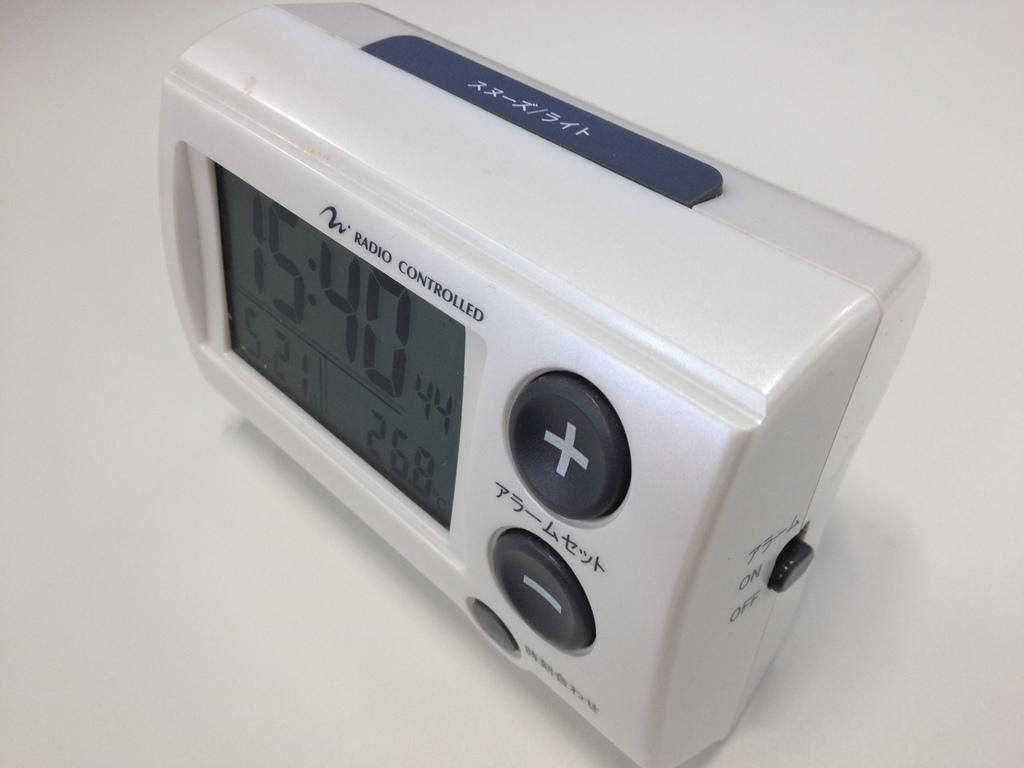<image>
Relay a brief, clear account of the picture shown. A which digital clock which says Radio Controlled on the front of the clock. 